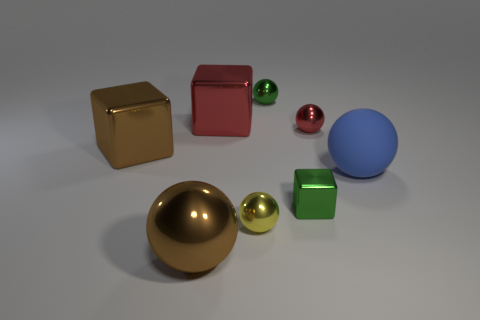Is there anything else that has the same material as the big blue object?
Offer a terse response. No. There is a metal block that is on the right side of the yellow thing; does it have the same size as the tiny yellow sphere?
Ensure brevity in your answer.  Yes. There is a green metal object to the right of the tiny green ball to the right of the red cube; what size is it?
Your answer should be very brief. Small. The big ball right of the small green metallic cube is what color?
Your answer should be very brief. Blue. What size is the green cube that is made of the same material as the large brown block?
Your answer should be compact. Small. What number of other big matte things have the same shape as the large red object?
Your response must be concise. 0. What material is the brown ball that is the same size as the blue thing?
Make the answer very short. Metal. Are there any blue objects made of the same material as the tiny yellow ball?
Ensure brevity in your answer.  No. There is a large metal thing that is both behind the yellow shiny object and on the left side of the large red metal thing; what is its color?
Ensure brevity in your answer.  Brown. How many other objects are the same color as the small metallic block?
Your response must be concise. 1. 